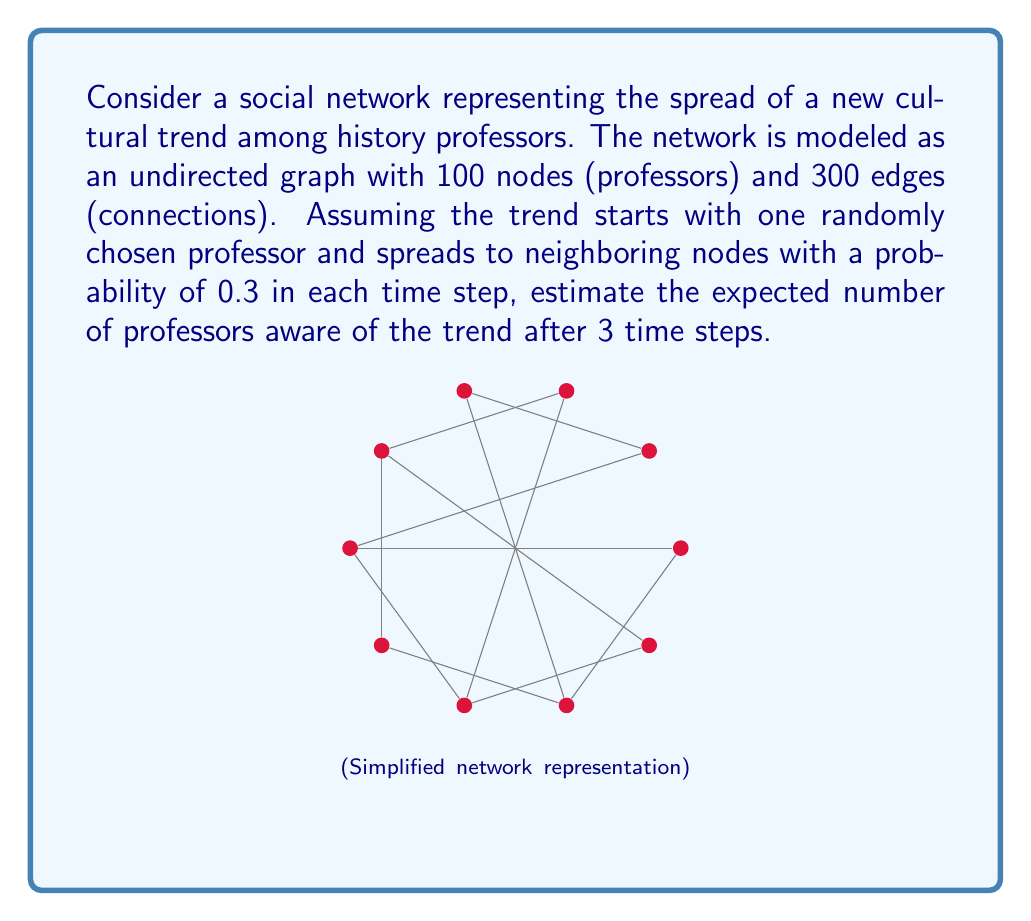Help me with this question. Let's approach this step-by-step:

1) First, we need to calculate the average degree of each node:
   Average degree = $\frac{2 \times \text{number of edges}}{\text{number of nodes}} = \frac{2 \times 300}{100} = 6$

2) In each time step, a node that knows the trend will inform its neighbors with a probability of 0.3. So, on average, each informed node will inform:
   $6 \times 0.3 = 1.8$ new nodes per time step

3) We can model this as a branching process. Let's calculate the expected number of informed nodes at each step:

   Step 0: 1 node (initial)
   Step 1: $1 + 1.8 = 2.8$ nodes
   Step 2: $2.8 + 2.8 \times 1.8 = 7.84$ nodes
   Step 3: $7.84 + 7.84 \times 1.8 = 21.952$ nodes

4) However, this calculation assumes an infinite network. In reality, as more nodes become informed, the spread will slow down due to overlapping connections and the finite size of the network.

5) A more accurate estimate can be obtained using the formula:

   $N_t = N \left(1 - \left(1 - \frac{1}{N}\right)^{R_0^t}\right)$

   Where:
   $N_t$ is the number of informed nodes at time $t$
   $N$ is the total number of nodes (100 in this case)
   $R_0$ is the basic reproduction number (1.8 in this case)
   $t$ is the number of time steps

6) Applying this formula for $t = 3$:

   $N_3 = 100 \left(1 - \left(1 - \frac{1}{100}\right)^{1.8^3}\right)$
        $= 100 \left(1 - (0.99)^{5.832}\right)$
        $\approx 20.33$

Therefore, after 3 time steps, we expect approximately 20 professors to be aware of the trend.
Answer: 20 professors 